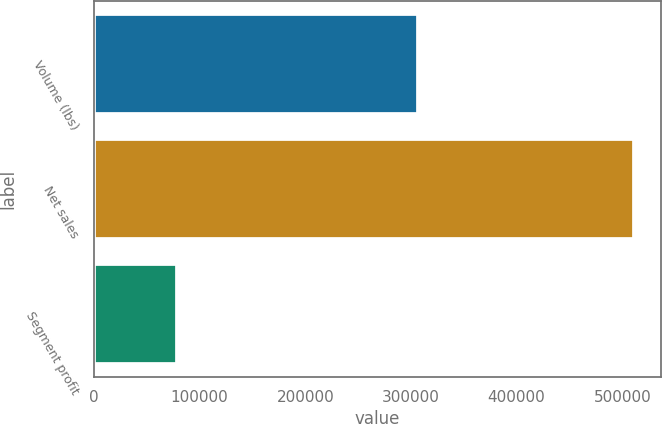Convert chart. <chart><loc_0><loc_0><loc_500><loc_500><bar_chart><fcel>Volume (lbs)<fcel>Net sales<fcel>Segment profit<nl><fcel>307127<fcel>511193<fcel>78409<nl></chart> 